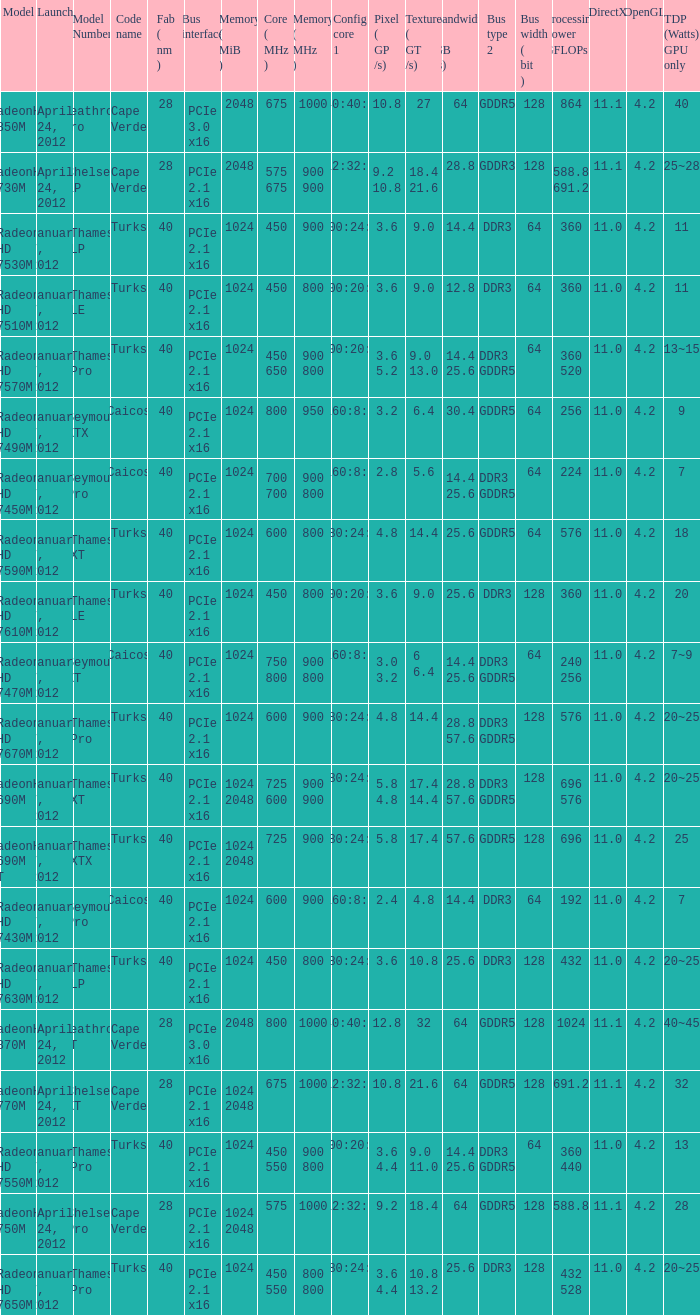Could you parse the entire table? {'header': ['Model', 'Launch', 'Model Number', 'Code name', 'Fab ( nm )', 'Bus interface', 'Memory ( MiB )', 'Core ( MHz )', 'Memory ( MHz )', 'Config core 1', 'Pixel ( GP /s)', 'Texture ( GT /s)', 'Bandwidth ( GB /s)', 'Bus type 2', 'Bus width ( bit )', 'Processing Power GFLOPs', 'DirectX', 'OpenGL', 'TDP (Watts) GPU only'], 'rows': [['RadeonHD 7850M', 'April 24, 2012', 'Heathrow Pro', 'Cape Verde', '28', 'PCIe 3.0 x16', '2048', '675', '1000', '640:40:16', '10.8', '27', '64', 'GDDR5', '128', '864', '11.1', '4.2', '40'], ['RadeonHD 7730M', 'April 24, 2012', 'Chelsea LP', 'Cape Verde', '28', 'PCIe 2.1 x16', '2048', '575 675', '900 900', '512:32:16', '9.2 10.8', '18.4 21.6', '28.8', 'GDDR3', '128', '588.8 691.2', '11.1', '4.2', '25~28'], ['Radeon HD 7530M', 'January 7, 2012', 'Thames LP', 'Turks', '40', 'PCIe 2.1 x16', '1024', '450', '900', '400:24:8', '3.6', '9.0', '14.4', 'DDR3', '64', '360', '11.0', '4.2', '11'], ['Radeon HD 7510M', 'January 7, 2012', 'Thames LE', 'Turks', '40', 'PCIe 2.1 x16', '1024', '450', '800', '400:20:8', '3.6', '9.0', '12.8', 'DDR3', '64', '360', '11.0', '4.2', '11'], ['Radeon HD 7570M', 'January 7, 2012', 'Thames Pro', 'Turks', '40', 'PCIe 2.1 x16', '1024', '450 650', '900 800', '400:20:8', '3.6 5.2', '9.0 13.0', '14.4 25.6', 'DDR3 GDDR5', '64', '360 520', '11.0', '4.2', '13~15'], ['Radeon HD 7490M', 'January 7, 2012', 'Seymour XTX', 'Caicos', '40', 'PCIe 2.1 x16', '1024', '800', '950', '160:8:4', '3.2', '6.4', '30.4', 'GDDR5', '64', '256', '11.0', '4.2', '9'], ['Radeon HD 7450M', 'January 7, 2012', 'Seymour Pro', 'Caicos', '40', 'PCIe 2.1 x16', '1024', '700 700', '900 800', '160:8:4', '2.8', '5.6', '14.4 25.6', 'DDR3 GDDR5', '64', '224', '11.0', '4.2', '7'], ['Radeon HD 7590M', 'January 7, 2012', 'Thames XT', 'Turks', '40', 'PCIe 2.1 x16', '1024', '600', '800', '480:24:8', '4.8', '14.4', '25.6', 'GDDR5', '64', '576', '11.0', '4.2', '18'], ['Radeon HD 7610M', 'January 7, 2012', 'Thames LE', 'Turks', '40', 'PCIe 2.1 x16', '1024', '450', '800', '400:20:8', '3.6', '9.0', '25.6', 'DDR3', '128', '360', '11.0', '4.2', '20'], ['Radeon HD 7470M', 'January 7, 2012', 'Seymour XT', 'Caicos', '40', 'PCIe 2.1 x16', '1024', '750 800', '900 800', '160:8:4', '3.0 3.2', '6 6.4', '14.4 25.6', 'DDR3 GDDR5', '64', '240 256', '11.0', '4.2', '7~9'], ['Radeon HD 7670M', 'January 7, 2012', 'Thames Pro', 'Turks', '40', 'PCIe 2.1 x16', '1024', '600', '900', '480:24:8', '4.8', '14.4', '28.8 57.6', 'DDR3 GDDR5', '128', '576', '11.0', '4.2', '20~25'], ['RadeonHD 7690M', 'January 7, 2012', 'Thames XT', 'Turks', '40', 'PCIe 2.1 x16', '1024 2048', '725 600', '900 900', '480:24:8', '5.8 4.8', '17.4 14.4', '28.8 57.6', 'DDR3 GDDR5', '128', '696 576', '11.0', '4.2', '20~25'], ['RadeonHD 7690M XT', 'January 7, 2012', 'Thames XTX', 'Turks', '40', 'PCIe 2.1 x16', '1024 2048', '725', '900', '480:24:8', '5.8', '17.4', '57.6', 'GDDR5', '128', '696', '11.0', '4.2', '25'], ['Radeon HD 7430M', 'January 7, 2012', 'Seymour Pro', 'Caicos', '40', 'PCIe 2.1 x16', '1024', '600', '900', '160:8:4', '2.4', '4.8', '14.4', 'DDR3', '64', '192', '11.0', '4.2', '7'], ['Radeon HD 7630M', 'January 7, 2012', 'Thames LP', 'Turks', '40', 'PCIe 2.1 x16', '1024', '450', '800', '480:24:8', '3.6', '10.8', '25.6', 'DDR3', '128', '432', '11.0', '4.2', '20~25'], ['RadeonHD 7870M', 'April 24, 2012', 'Heathrow XT', 'Cape Verde', '28', 'PCIe 3.0 x16', '2048', '800', '1000', '640:40:16', '12.8', '32', '64', 'GDDR5', '128', '1024', '11.1', '4.2', '40~45'], ['RadeonHD 7770M', 'April 24, 2012', 'Chelsea XT', 'Cape Verde', '28', 'PCIe 2.1 x16', '1024 2048', '675', '1000', '512:32:16', '10.8', '21.6', '64', 'GDDR5', '128', '691.2', '11.1', '4.2', '32'], ['Radeon HD 7550M', 'January 7, 2012', 'Thames Pro', 'Turks', '40', 'PCIe 2.1 x16', '1024', '450 550', '900 800', '400:20:8', '3.6 4.4', '9.0 11.0', '14.4 25.6', 'DDR3 GDDR5', '64', '360 440', '11.0', '4.2', '13'], ['RadeonHD 7750M', 'April 24, 2012', 'Chelsea Pro', 'Cape Verde', '28', 'PCIe 2.1 x16', '1024 2048', '575', '1000', '512:32:16', '9.2', '18.4', '64', 'GDDR5', '128', '588.8', '11.1', '4.2', '28'], ['Radeon HD 7650M', 'January 7, 2012', 'Thames Pro', 'Turks', '40', 'PCIe 2.1 x16', '1024', '450 550', '800 800', '480:24:8', '3.6 4.4', '10.8 13.2', '25.6', 'DDR3', '128', '432 528', '11.0', '4.2', '20~25']]} What was the model's DirectX if it has a Core of 700 700 mhz? 11.0. 